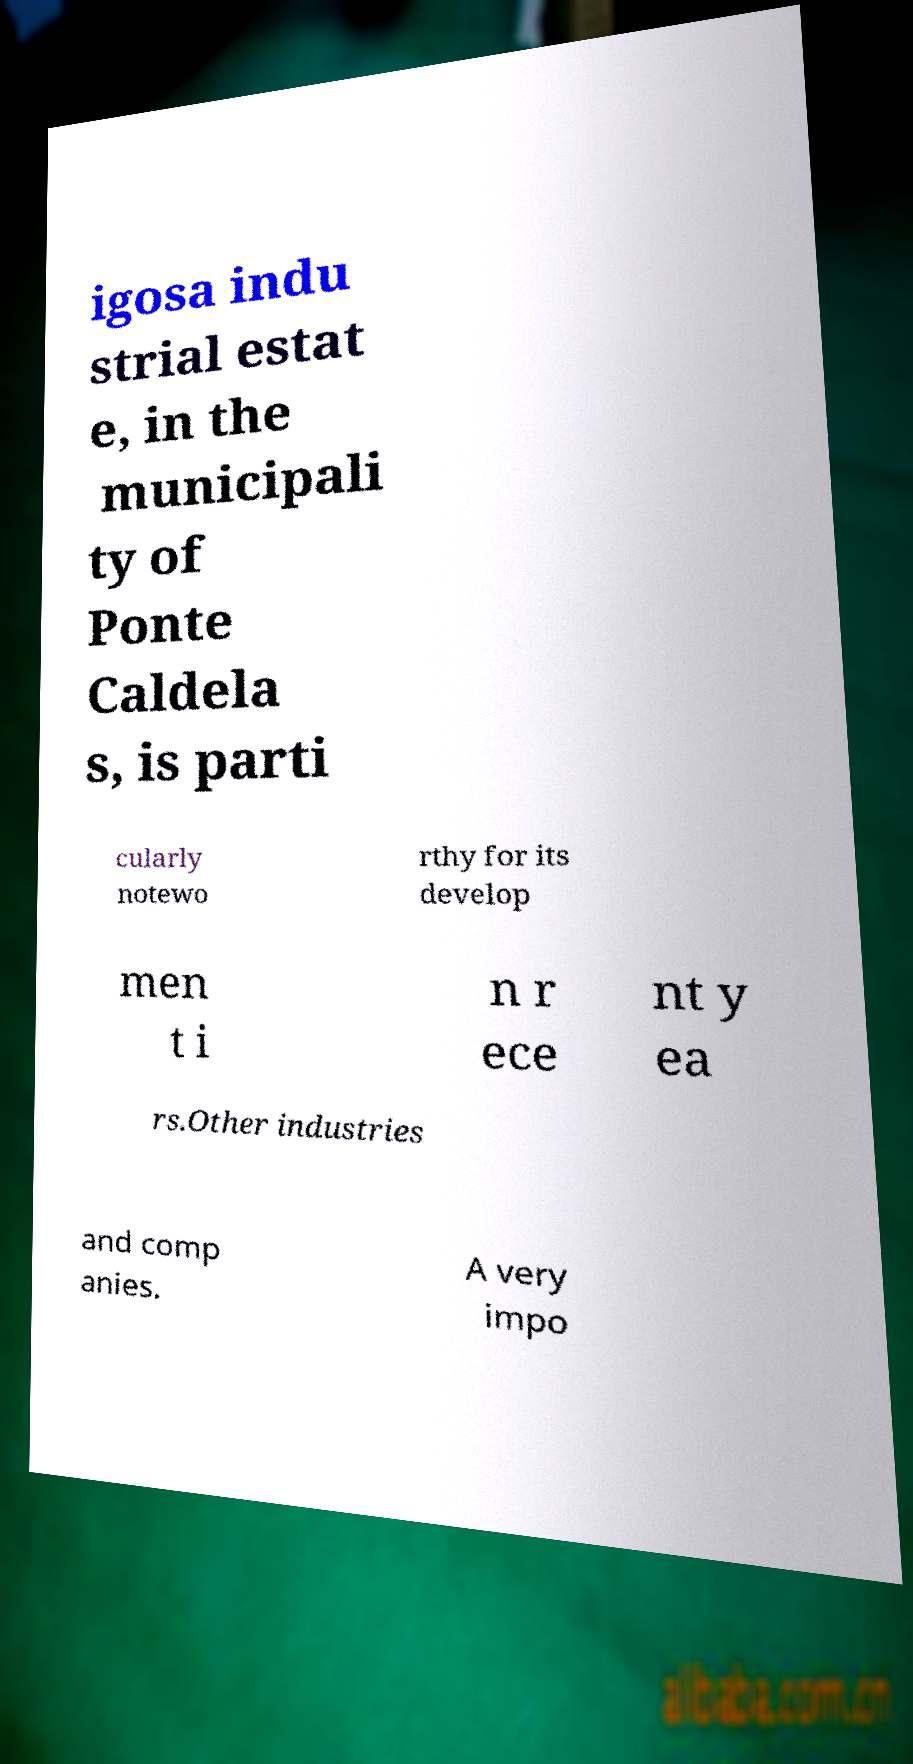Please read and relay the text visible in this image. What does it say? igosa indu strial estat e, in the municipali ty of Ponte Caldela s, is parti cularly notewo rthy for its develop men t i n r ece nt y ea rs.Other industries and comp anies. A very impo 